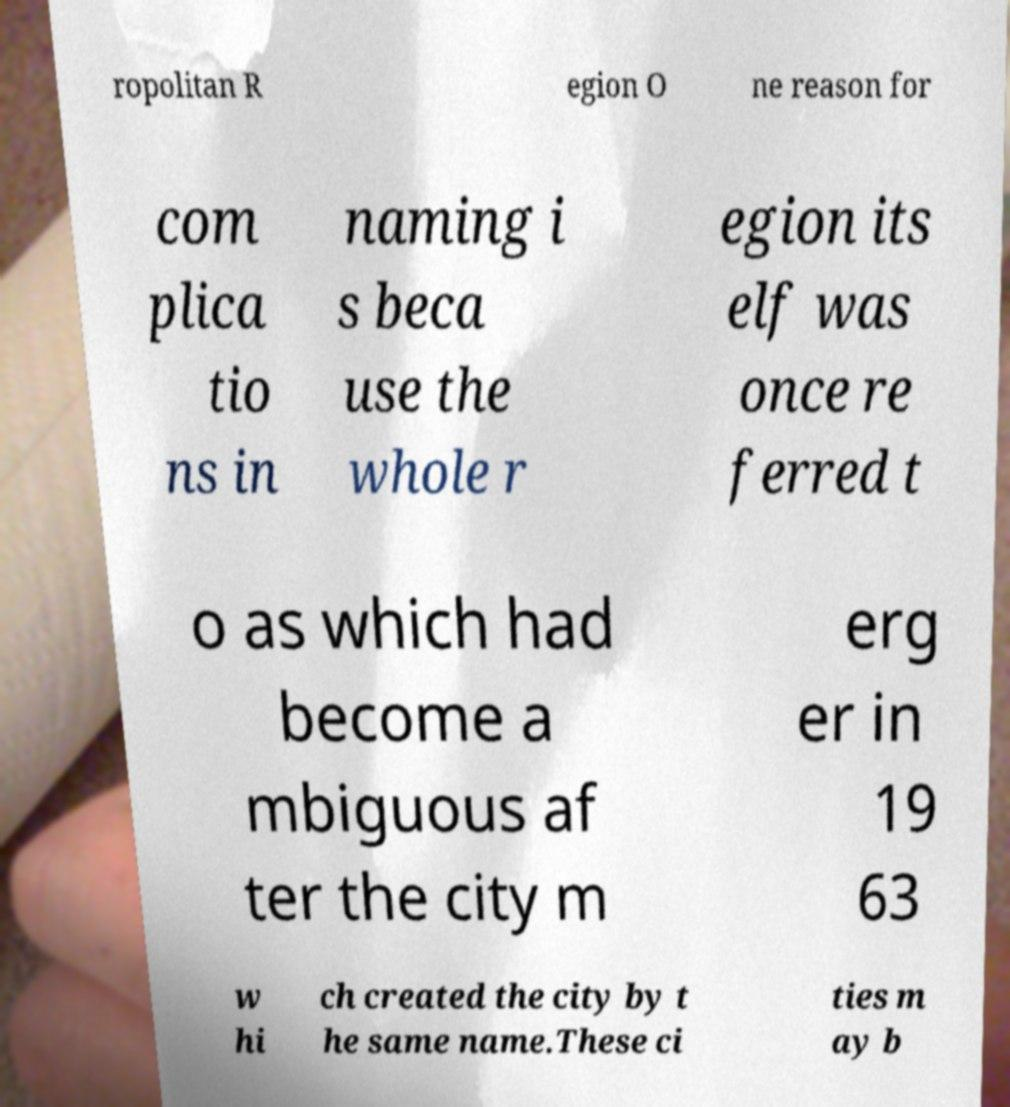Can you read and provide the text displayed in the image?This photo seems to have some interesting text. Can you extract and type it out for me? ropolitan R egion O ne reason for com plica tio ns in naming i s beca use the whole r egion its elf was once re ferred t o as which had become a mbiguous af ter the city m erg er in 19 63 w hi ch created the city by t he same name.These ci ties m ay b 